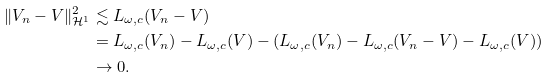Convert formula to latex. <formula><loc_0><loc_0><loc_500><loc_500>\| V _ { n } - V \| _ { \mathcal { H } ^ { 1 } } ^ { 2 } & \lesssim L _ { \omega , c } ( V _ { n } - V ) \\ & = L _ { \omega , c } ( V _ { n } ) - L _ { \omega , c } ( V ) - ( L _ { \omega , c } ( V _ { n } ) - L _ { \omega , c } ( V _ { n } - V ) - L _ { \omega , c } ( V ) ) \\ & \rightarrow 0 .</formula> 